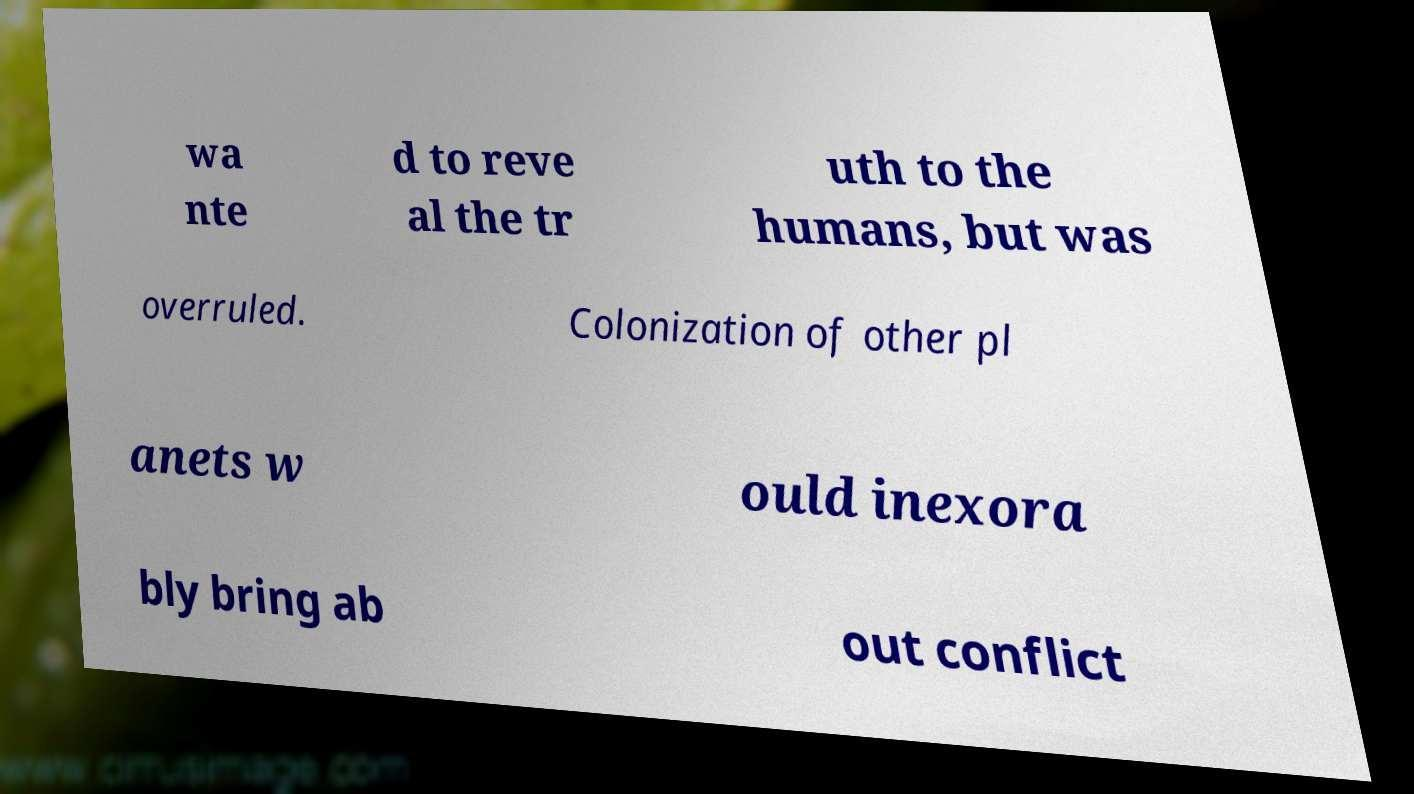Can you accurately transcribe the text from the provided image for me? wa nte d to reve al the tr uth to the humans, but was overruled. Colonization of other pl anets w ould inexora bly bring ab out conflict 